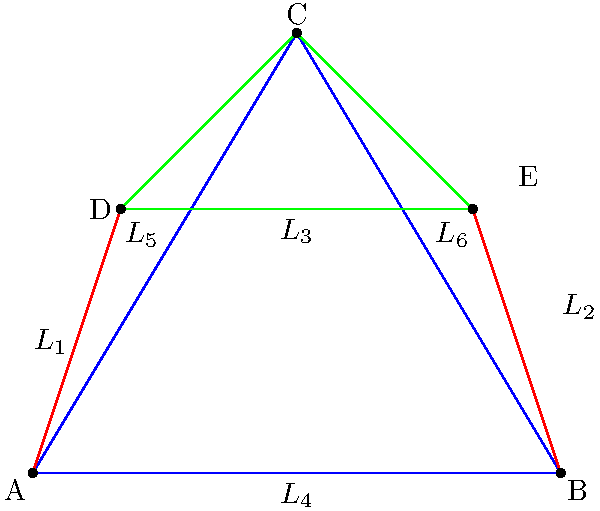In this modern art-inspired geometric design, six lines intersect to form a complex pattern. The lines are defined as follows:

$L_1: y = 3x$
$L_2: y = -\frac{1}{2}x + 6$
$L_3: y = 3$
$L_4: y = 0$
$L_5: y = \frac{5}{3}x$
$L_6: y = -\frac{5}{3}x + 10$

How many distinct intersection points are there in this design? To find the number of distinct intersection points, we need to determine where each line intersects with the others:

1) $L_1$ and $L_2$ intersect at $(\frac{12}{7}, \frac{36}{7})$
2) $L_1$ and $L_3$ intersect at $(1, 3)$
3) $L_1$ and $L_4$ intersect at $(0, 0)$
4) $L_1$ and $L_5$ intersect at $(0, 0)$ (same as #3)
5) $L_1$ and $L_6$ intersect at $(3, 9)$, which is outside our design
6) $L_2$ and $L_3$ intersect at $(6, 3)$
7) $L_2$ and $L_4$ intersect at $(12, 0)$, which is outside our design
8) $L_2$ and $L_5$ intersect at $(\frac{18}{7}, \frac{30}{7})$
9) $L_2$ and $L_6$ intersect at $(6, 0)$
10) $L_3$ and $L_4$ do not intersect (parallel)
11) $L_3$ and $L_5$ intersect at $(\frac{9}{5}, 3)$
12) $L_3$ and $L_6$ intersect at $(5, 3)$
13) $L_4$ and $L_5$ intersect at $(0, 0)$ (same as #3 and #4)
14) $L_4$ and $L_6$ intersect at $(6, 0)$ (same as #9)
15) $L_5$ and $L_6$ intersect at $(3, 5)$

Counting the distinct points within our design:
(0,0), (1,3), (6,3), (3,5), $(\frac{12}{7}, \frac{36}{7})$, $(\frac{18}{7}, \frac{30}{7})$, $(\frac{9}{5}, 3)$, (5,3), (6,0)

There are 9 distinct intersection points in this design.
Answer: 9 